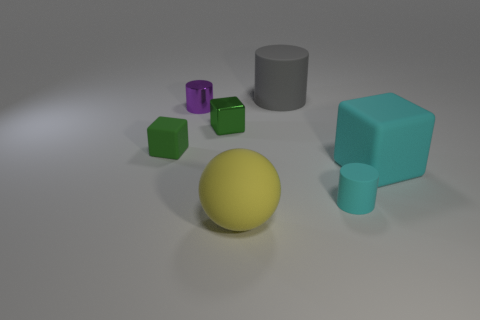Subtract all small metallic cylinders. How many cylinders are left? 2 Subtract all cyan blocks. How many blocks are left? 2 Subtract all balls. How many objects are left? 6 Add 1 gray things. How many objects exist? 8 Subtract 2 cylinders. How many cylinders are left? 1 Subtract all gray balls. How many green cubes are left? 2 Subtract all small blue cylinders. Subtract all large cylinders. How many objects are left? 6 Add 7 tiny purple things. How many tiny purple things are left? 8 Add 5 big gray things. How many big gray things exist? 6 Subtract 1 purple cylinders. How many objects are left? 6 